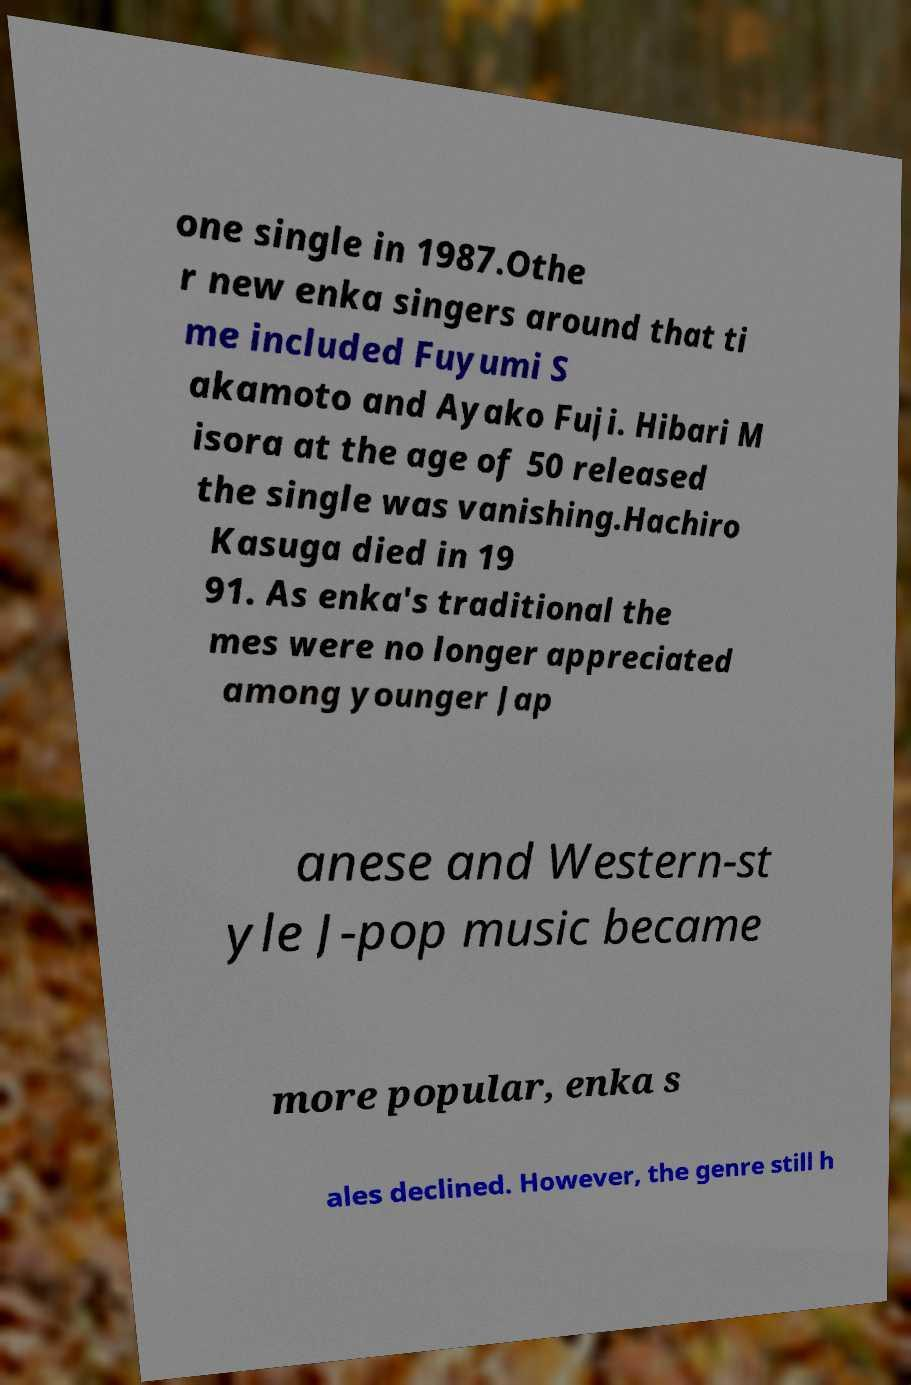Please read and relay the text visible in this image. What does it say? one single in 1987.Othe r new enka singers around that ti me included Fuyumi S akamoto and Ayako Fuji. Hibari M isora at the age of 50 released the single was vanishing.Hachiro Kasuga died in 19 91. As enka's traditional the mes were no longer appreciated among younger Jap anese and Western-st yle J-pop music became more popular, enka s ales declined. However, the genre still h 